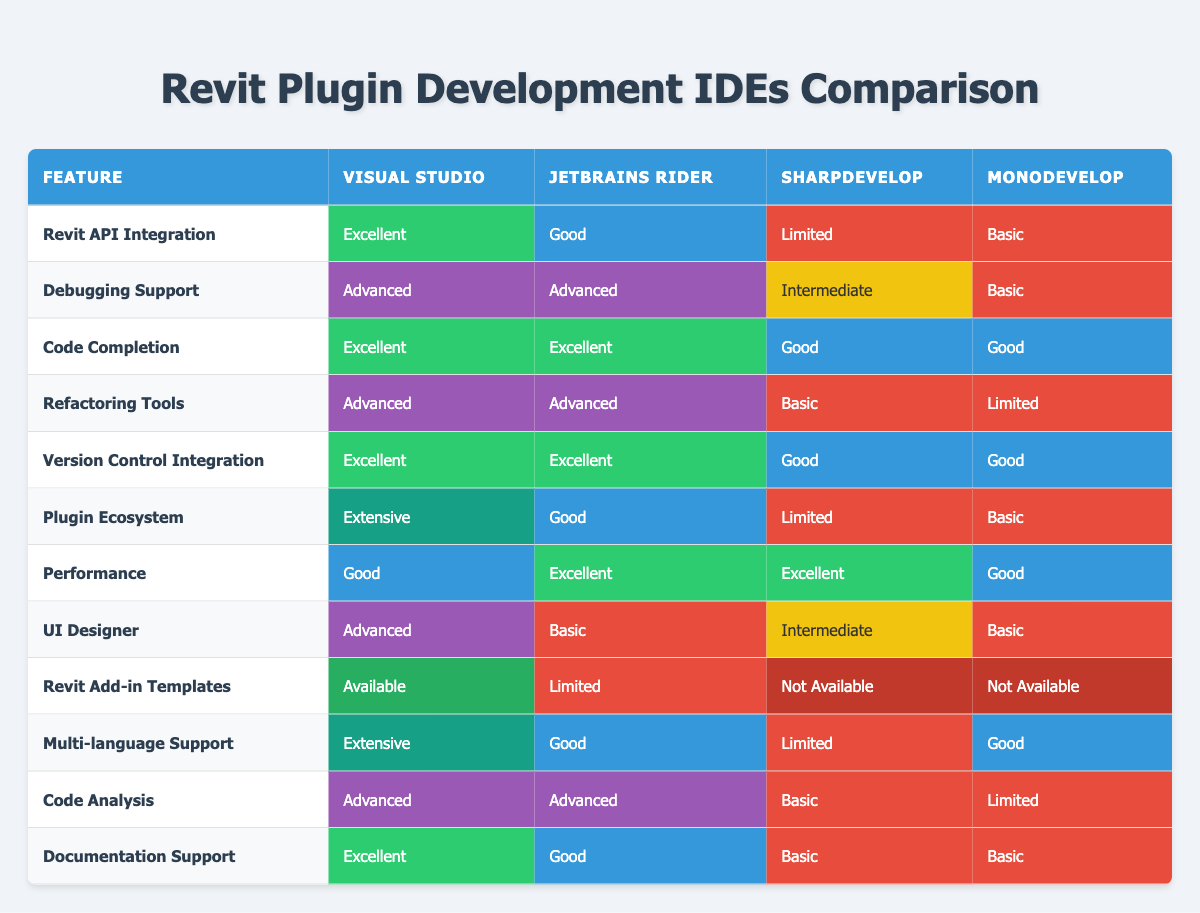What is the debugging support level in JetBrains Rider? The table shows that JetBrains Rider has "Advanced" debugging support. This value is directly taken from the corresponding cell in the Debugging Support row.
Answer: Advanced Which IDE has the best Revit API integration? According to the table, Visual Studio offers "Excellent" Revit API Integration, while the other IDEs provide lower levels such as "Good," "Limited," and "Basic." Thus, Visual Studio has the best integration.
Answer: Visual Studio Is there any IDE that offers Revit Add-in Templates? The table indicates that Visual Studio is the only IDE with "Available" Revit Add-in Templates. SharpDevelop and MonoDevelop have "Not Available," while JetBrains Rider has "Limited." Therefore, there is only one IDE that provides this feature.
Answer: Yes What is the average performance rating of all listed IDEs? To calculate the average, we first convert the ratings to a numerical scale: Excellent (3), Good (2), Advanced (2), Intermediate (1.5), Basic (1), Limited (1), Not Available (0). According to the ratings: Visual Studio (2), JetBrains Rider (3), SharpDevelop (3), and MonoDevelop (2) add up to 10/4 = 2.5. Therefore, the average performance rating is thus 2.5.
Answer: 2.5 Which IDE has the most extensive plugin ecosystem? Visual Studio has an "Extensive" rating in the Plugin Ecosystem row. The other IDEs are rated "Good," "Limited," and "Basic." Therefore, Visual Studio has the most extensive ecosystem compared to the others.
Answer: Visual Studio How does the version control integration in MonoDevelop compare to that in SharpDevelop? The version control integration in MonoDevelop is rated "Good," whereas SharpDevelop is rated "Good" as well. Thus, they offer equal integration capabilities in this regard.
Answer: Equal Is JetBrains Rider a better option for UI design support than SharpDevelop? From the table, JetBrains Rider has "Basic" UI Designer support while SharpDevelop has "Intermediate" support, meaning SharpDevelop provides a better option for UI design support.
Answer: No Which IDE performs better overall in terms of performance ratings? JetBrains Rider and SharpDevelop both have an "Excellent" performance rating, while Visual Studio and MonoDevelop have a "Good" rating. Since JetBrains Rider and SharpDevelop are rated higher, they perform better overall.
Answer: JetBrains Rider and SharpDevelop How many IDEs provide Advanced Code Analysis? The table shows that both Visual Studio and JetBrains Rider are rated "Advanced" in Code Analysis. SharpDevelop has "Basic," and MonoDevelop has "Limited." Thus, only 2 IDEs provide Advanced Code Analysis.
Answer: 2 